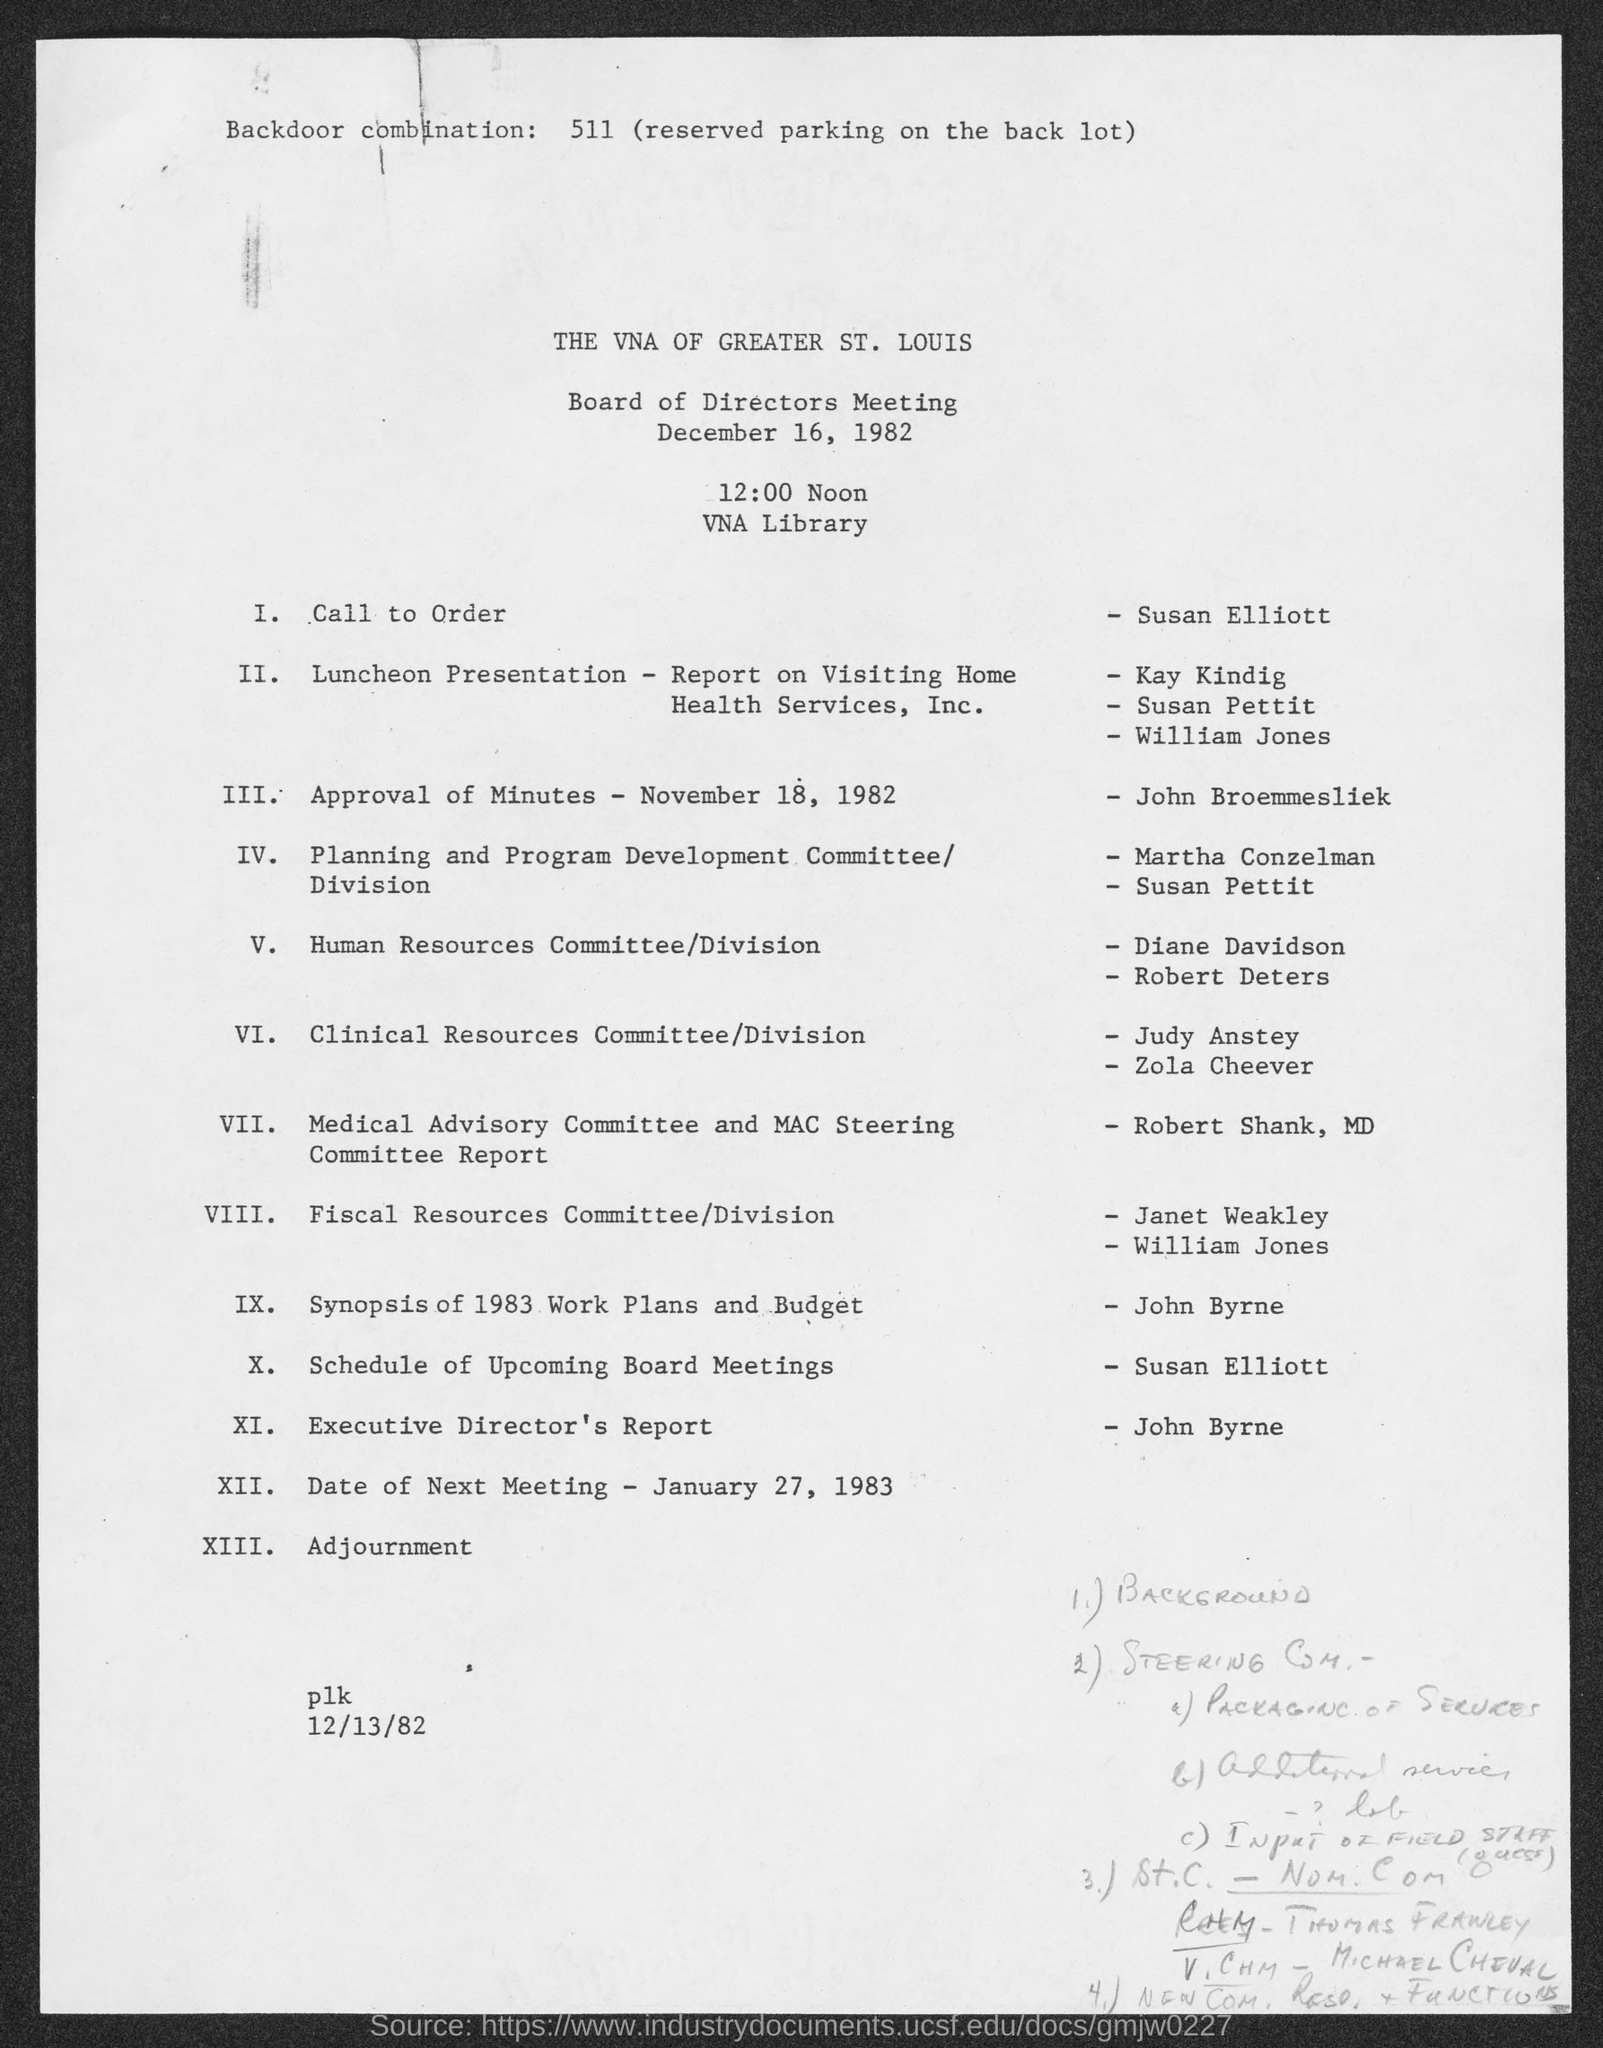Outline some significant characteristics in this image. The date of the next meeting as per the agenda is January 27, 1983. The session on the schedule of upcoming board meetings will be presented by Susan Elliott. The Board of Directors Meeting is organized at the VNA Library. 